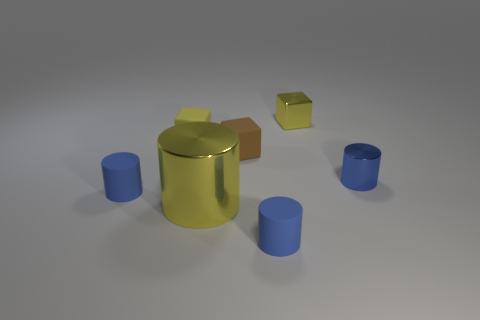How many blue cylinders must be subtracted to get 1 blue cylinders? 2 Subtract all yellow spheres. How many blue cylinders are left? 3 Add 1 rubber cylinders. How many objects exist? 8 Subtract all blocks. How many objects are left? 4 Add 3 brown things. How many brown things exist? 4 Subtract 0 yellow spheres. How many objects are left? 7 Subtract all tiny yellow metal objects. Subtract all big things. How many objects are left? 5 Add 4 big things. How many big things are left? 5 